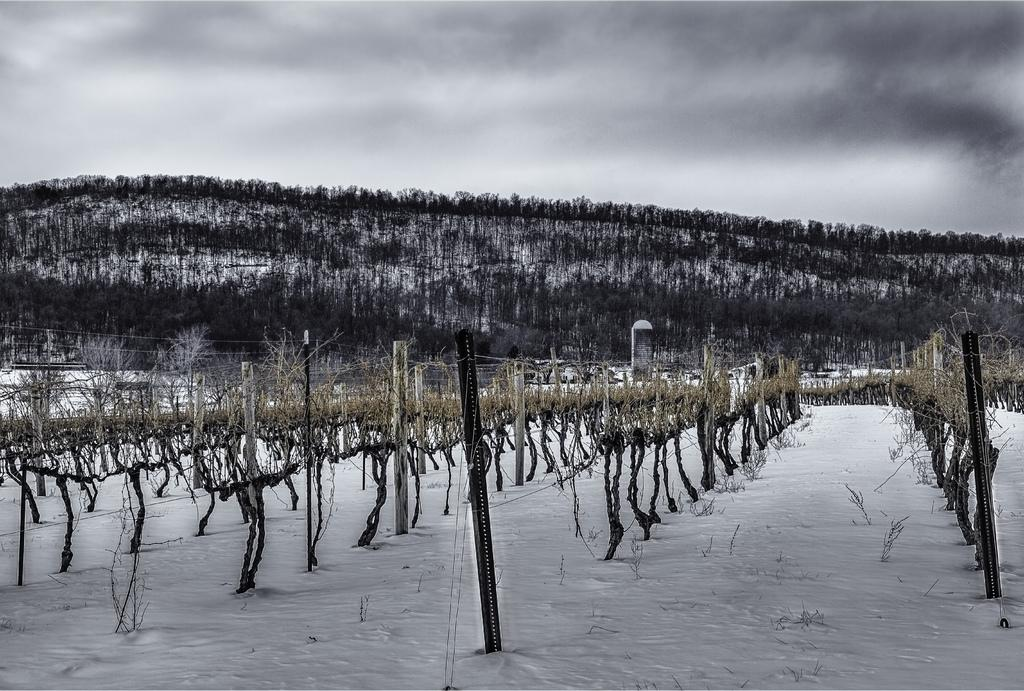What type of objects can be seen in the image that are made of metal? There are metal rods in the image. What type of natural elements are present in the image? There are trees in the image. What type of architectural elements can be seen in the image? There are pillars in the image. How many donkeys are visible in the image? There are no donkeys present in the image. What type of hand can be seen interacting with the metal rods in the image? There are no hands visible in the image, let alone interacting with the metal rods. 